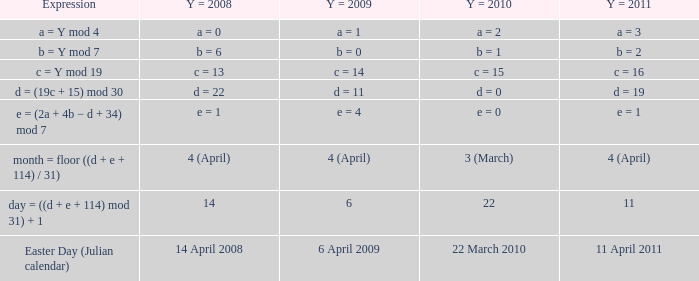What is the y = 2011 when the y = 2009 is 6 april 2009? 11 April 2011. 